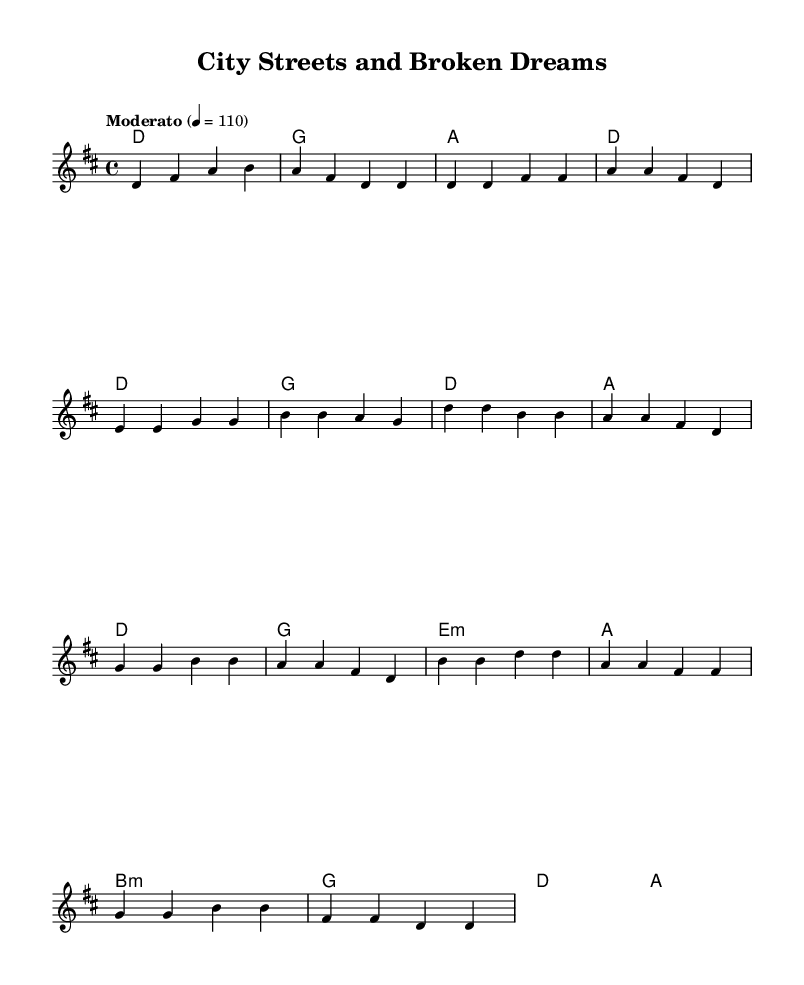What is the key signature of this music? The key signature is D major, which has two sharps (F# and C#). It can be identified by looking at the key signature indicated at the beginning of the sheet music.
Answer: D major What is the time signature of this music? The time signature is 4/4, which means there are four beats per measure. This is shown at the beginning of the score where the time signature is indicated.
Answer: 4/4 What is the tempo marking for this piece? The tempo marking is "Moderato," which suggests a moderate speed of performance. It is stated above the staff in the tempo indication.
Answer: Moderato How many measures are in the intro section? The intro consists of 4 measures, which can be counted by identifying the group of notes until the first section transition.
Answer: 4 What chord is played in the first measure? The chord in the first measure is D major, which can be identified in the harmonies section where it shows "d1" for the first chord.
Answer: D In which section does the bridge appear? The bridge appears after the chorus and before the final section. It’s indicated in the chord progression and melody. The content following the chorus leads into the bridge section.
Answer: Bridge What are the themes explored in this folk piece? The themes include urban issues and social matters, evident in the title "City Streets and Broken Dreams" and the lyrical content implied by the structure and melody.
Answer: Urban themes and social issues 